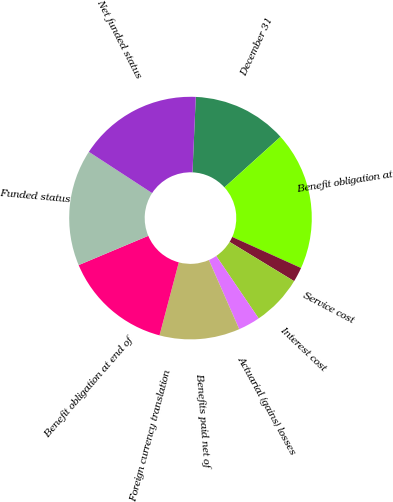Convert chart. <chart><loc_0><loc_0><loc_500><loc_500><pie_chart><fcel>December 31<fcel>Benefit obligation at<fcel>Service cost<fcel>Interest cost<fcel>Actuarial (gains) losses<fcel>Benefits paid net of<fcel>Foreign currency translation<fcel>Benefit obligation at end of<fcel>Funded status<fcel>Net funded status<nl><fcel>12.62%<fcel>18.44%<fcel>1.95%<fcel>6.8%<fcel>2.92%<fcel>10.68%<fcel>0.01%<fcel>14.56%<fcel>15.53%<fcel>16.5%<nl></chart> 